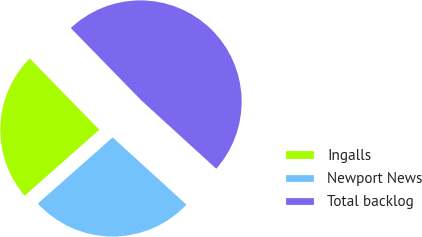Convert chart. <chart><loc_0><loc_0><loc_500><loc_500><pie_chart><fcel>Ingalls<fcel>Newport News<fcel>Total backlog<nl><fcel>24.22%<fcel>26.71%<fcel>49.07%<nl></chart> 